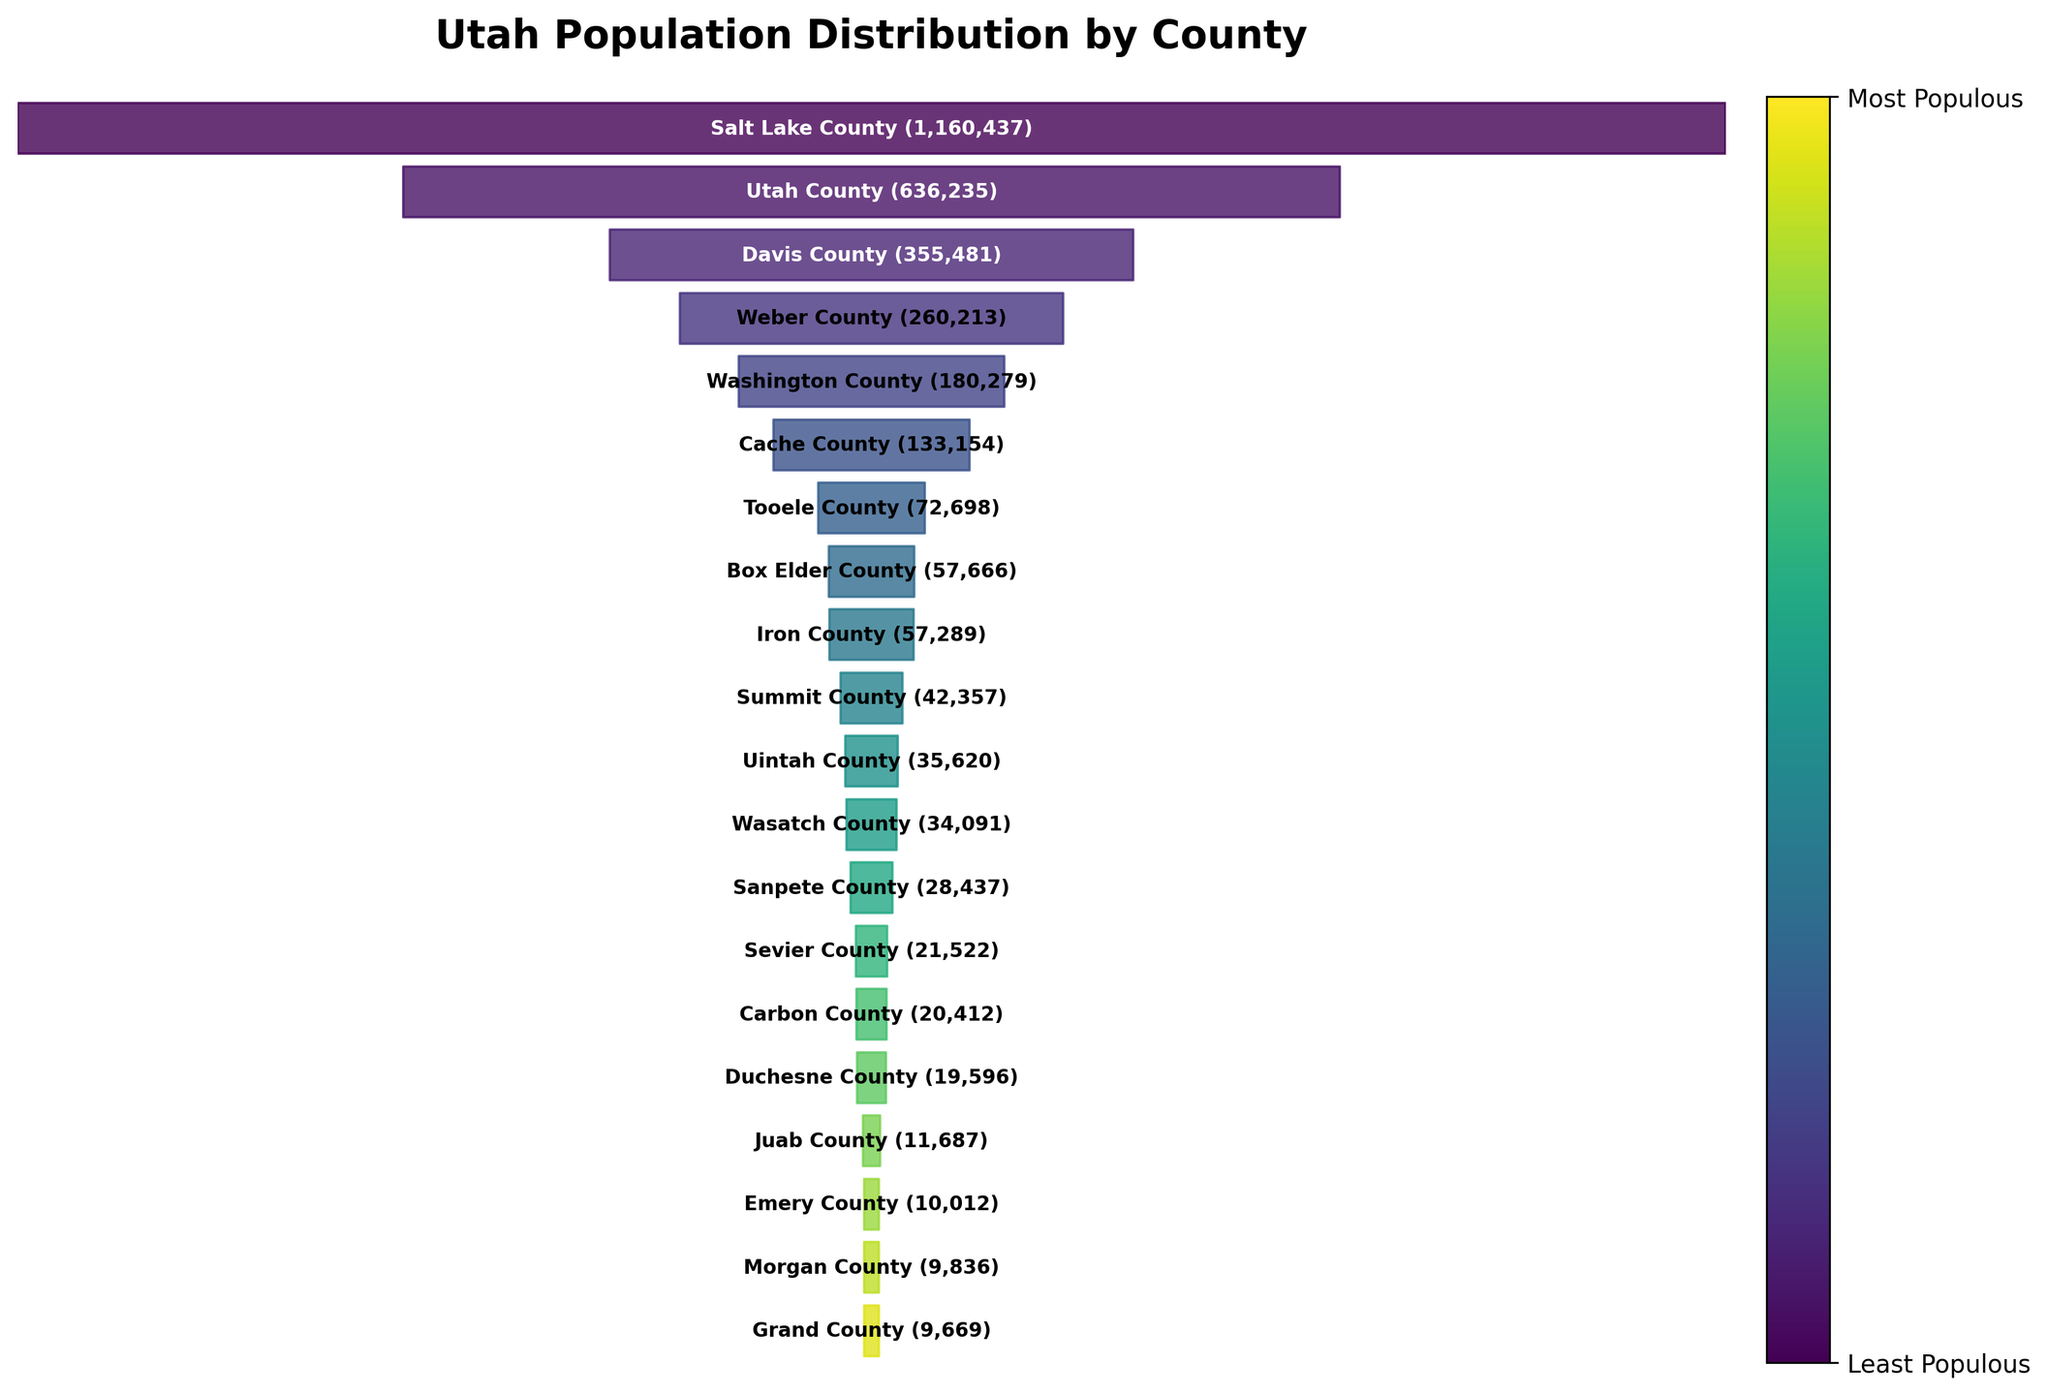What's the title of the figure? The title of the figure is usually found at the top of the chart. In this case, the title is "Utah Population Distribution by County" as specified in the code.
Answer: Utah Population Distribution by County Which county has the highest population? This can be determined by looking for the top entry in the funnel chart. The largest section at the top represents the county with the highest population, which is Salt Lake County with 1,160,437 people.
Answer: Salt Lake County How many counties are represented in the chart? The number of counties can be counted by looking at the distinct sections or entries in the funnel chart. According to the list, there are 20 counties in total.
Answer: 20 Which counties have a population higher than 500,000? By observing the segments, only Salt Lake County and Utah County have populations exceeding 500,000. Salt Lake County has 1,160,437 people, and Utah County has 636,235 people.
Answer: Salt Lake County, Utah County What is the difference in population between Salt Lake County and Utah County? The population of Salt Lake County is 1,160,437 and that of Utah County is 636,235. Subtracting the two numbers gives the difference: 1,160,437 - 636,235 = 524,202.
Answer: 524,202 Which county is the least populous? The smallest segment at the bottom of the funnel represents the least populous county, which is Grand County with a population of 9,669.
Answer: Grand County How does the population of Davis County compare to that of Weber County? Davis County's population (355,481) is compared with Weber County's population (260,213). Since 355,481 is greater than 260,213, Davis County has a higher population than Weber County.
Answer: Davis County has a higher population What is the combined population of Box Elder County and Iron County? The populations of Box Elder County (57,666) and Iron County (57,289) are added together. 57,666 + 57,289 = 114,955.
Answer: 114,955 Which counties have a population between 50,000 and 100,000? From the chart, the counties with populations in this range are Tooele County (72,698), Box Elder County (57,666), and Iron County (57,289).
Answer: Tooele County, Box Elder County, Iron County 